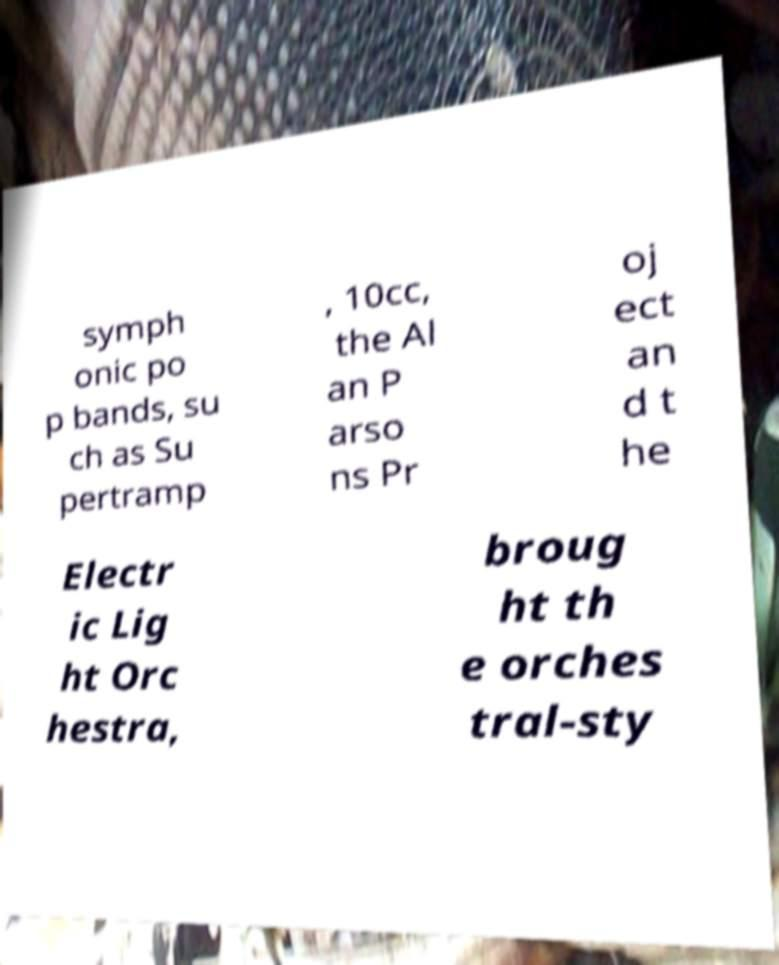Please read and relay the text visible in this image. What does it say? symph onic po p bands, su ch as Su pertramp , 10cc, the Al an P arso ns Pr oj ect an d t he Electr ic Lig ht Orc hestra, broug ht th e orches tral-sty 